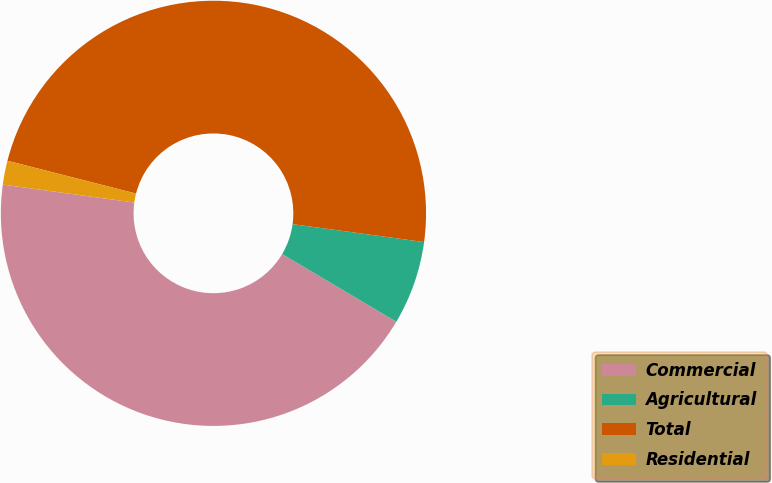Convert chart. <chart><loc_0><loc_0><loc_500><loc_500><pie_chart><fcel>Commercial<fcel>Agricultural<fcel>Total<fcel>Residential<nl><fcel>43.64%<fcel>6.36%<fcel>48.18%<fcel>1.82%<nl></chart> 